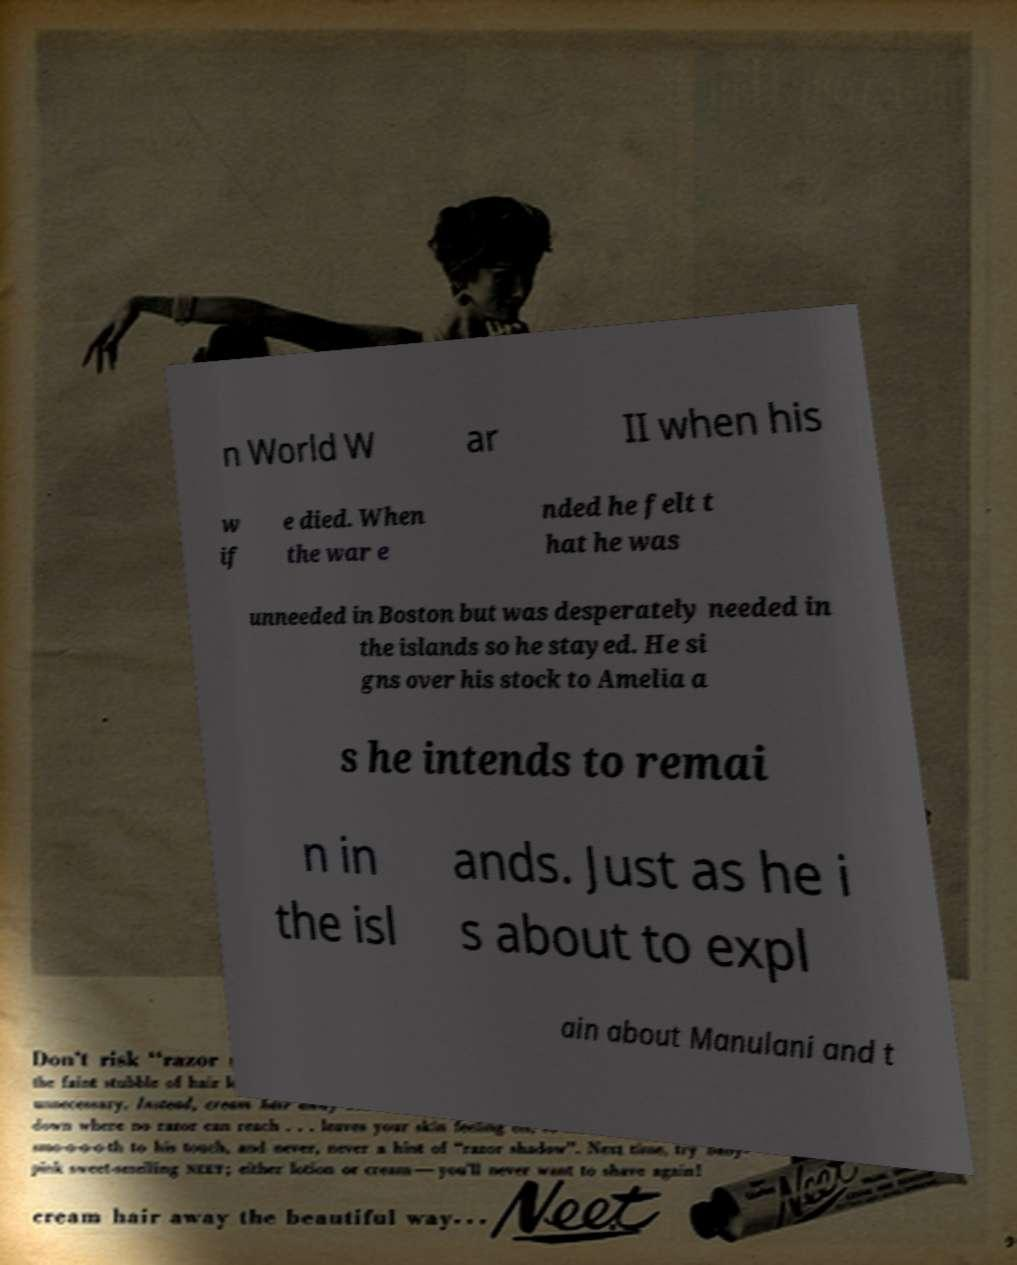For documentation purposes, I need the text within this image transcribed. Could you provide that? n World W ar II when his w if e died. When the war e nded he felt t hat he was unneeded in Boston but was desperately needed in the islands so he stayed. He si gns over his stock to Amelia a s he intends to remai n in the isl ands. Just as he i s about to expl ain about Manulani and t 